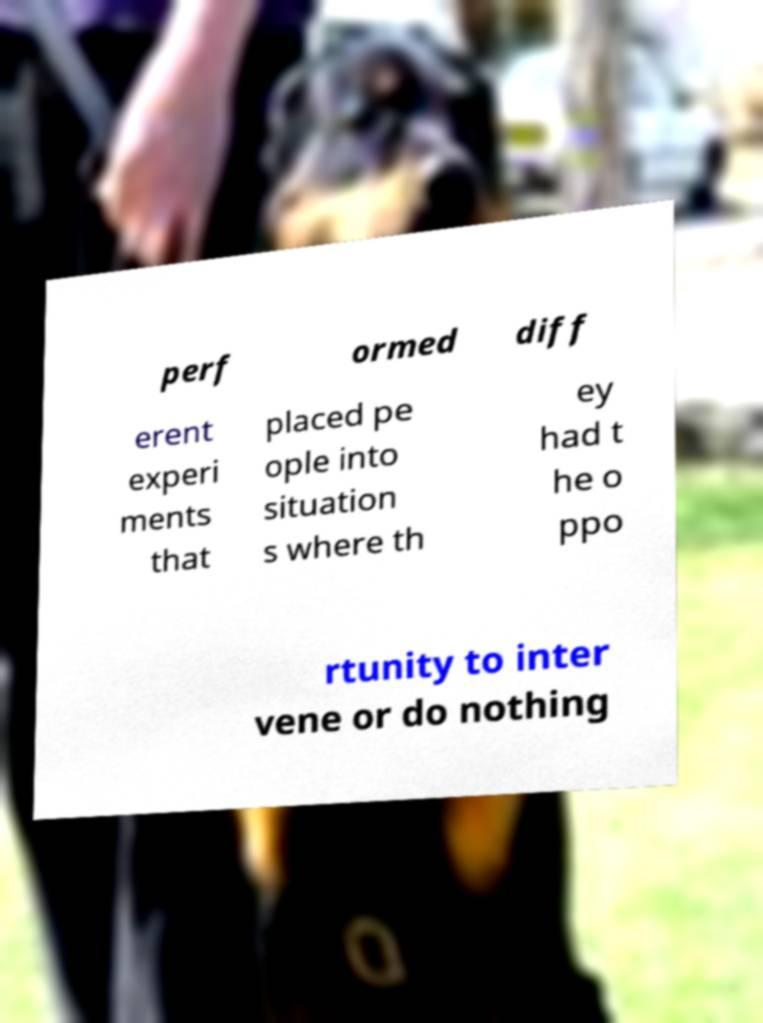Please identify and transcribe the text found in this image. perf ormed diff erent experi ments that placed pe ople into situation s where th ey had t he o ppo rtunity to inter vene or do nothing 